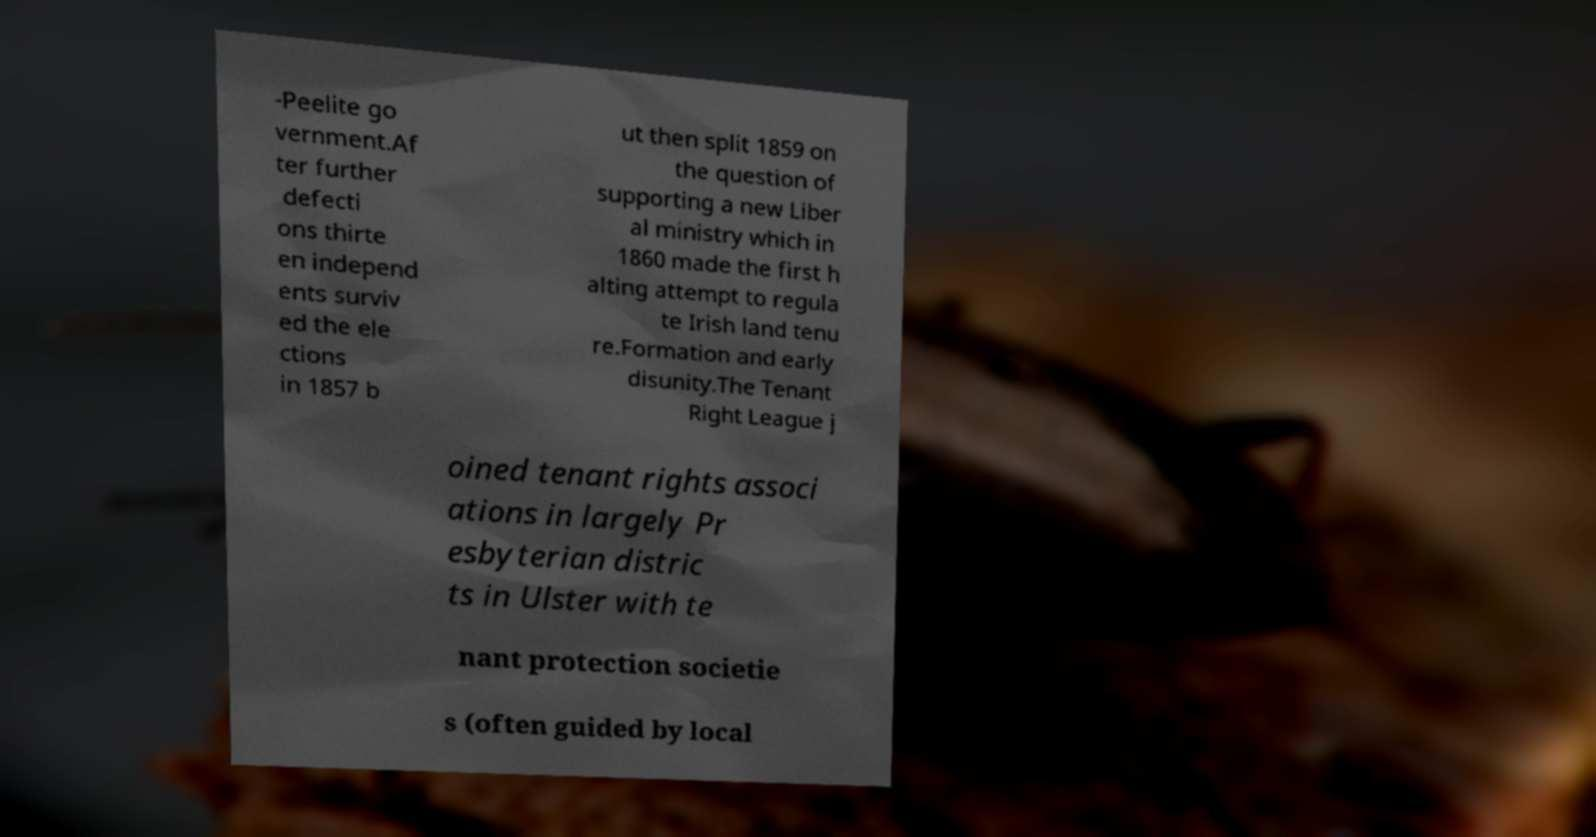Could you assist in decoding the text presented in this image and type it out clearly? -Peelite go vernment.Af ter further defecti ons thirte en independ ents surviv ed the ele ctions in 1857 b ut then split 1859 on the question of supporting a new Liber al ministry which in 1860 made the first h alting attempt to regula te Irish land tenu re.Formation and early disunity.The Tenant Right League j oined tenant rights associ ations in largely Pr esbyterian distric ts in Ulster with te nant protection societie s (often guided by local 